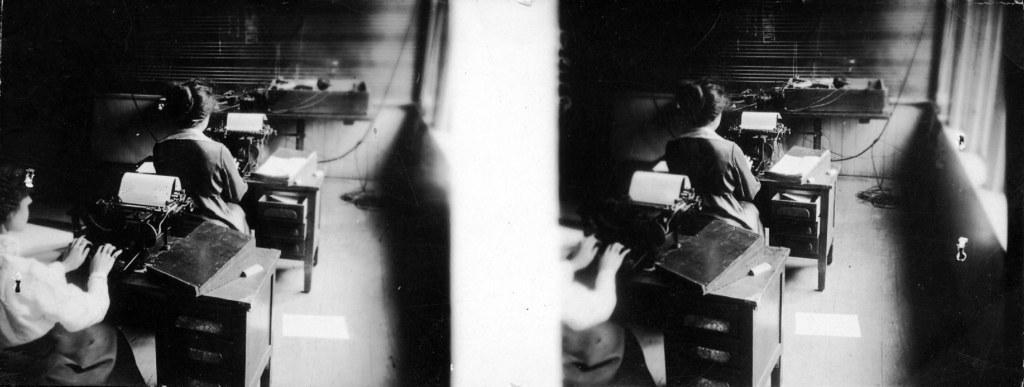Please provide a concise description of this image. In this picture I can see collage of two similar images and I can see couple of women seated and working on the typing machines on the tables and I can see papers on the tables. 